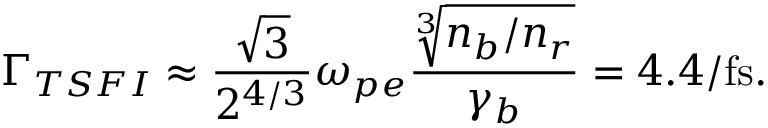<formula> <loc_0><loc_0><loc_500><loc_500>\Gamma _ { T S F I } \approx \frac { \sqrt { 3 } } { 2 ^ { 4 / 3 } } \omega _ { p e } \frac { \sqrt { [ } 3 ] { n _ { b } / n _ { r } } } { \gamma _ { b } } = 4 . 4 / f s .</formula> 